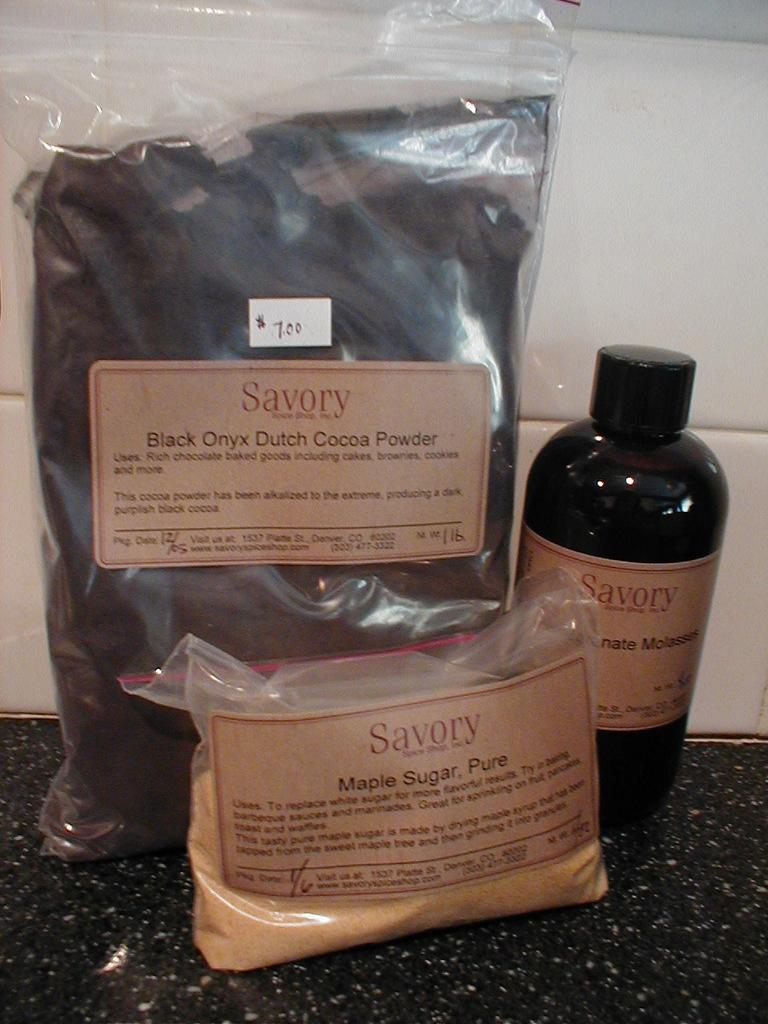<image>
Write a terse but informative summary of the picture. Black bottle of Savory next to a couple of bags. 